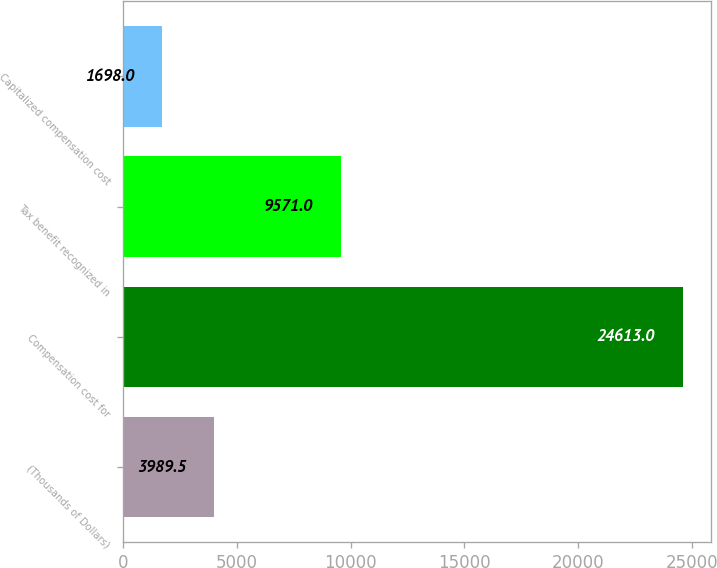<chart> <loc_0><loc_0><loc_500><loc_500><bar_chart><fcel>(Thousands of Dollars)<fcel>Compensation cost for<fcel>Tax benefit recognized in<fcel>Capitalized compensation cost<nl><fcel>3989.5<fcel>24613<fcel>9571<fcel>1698<nl></chart> 